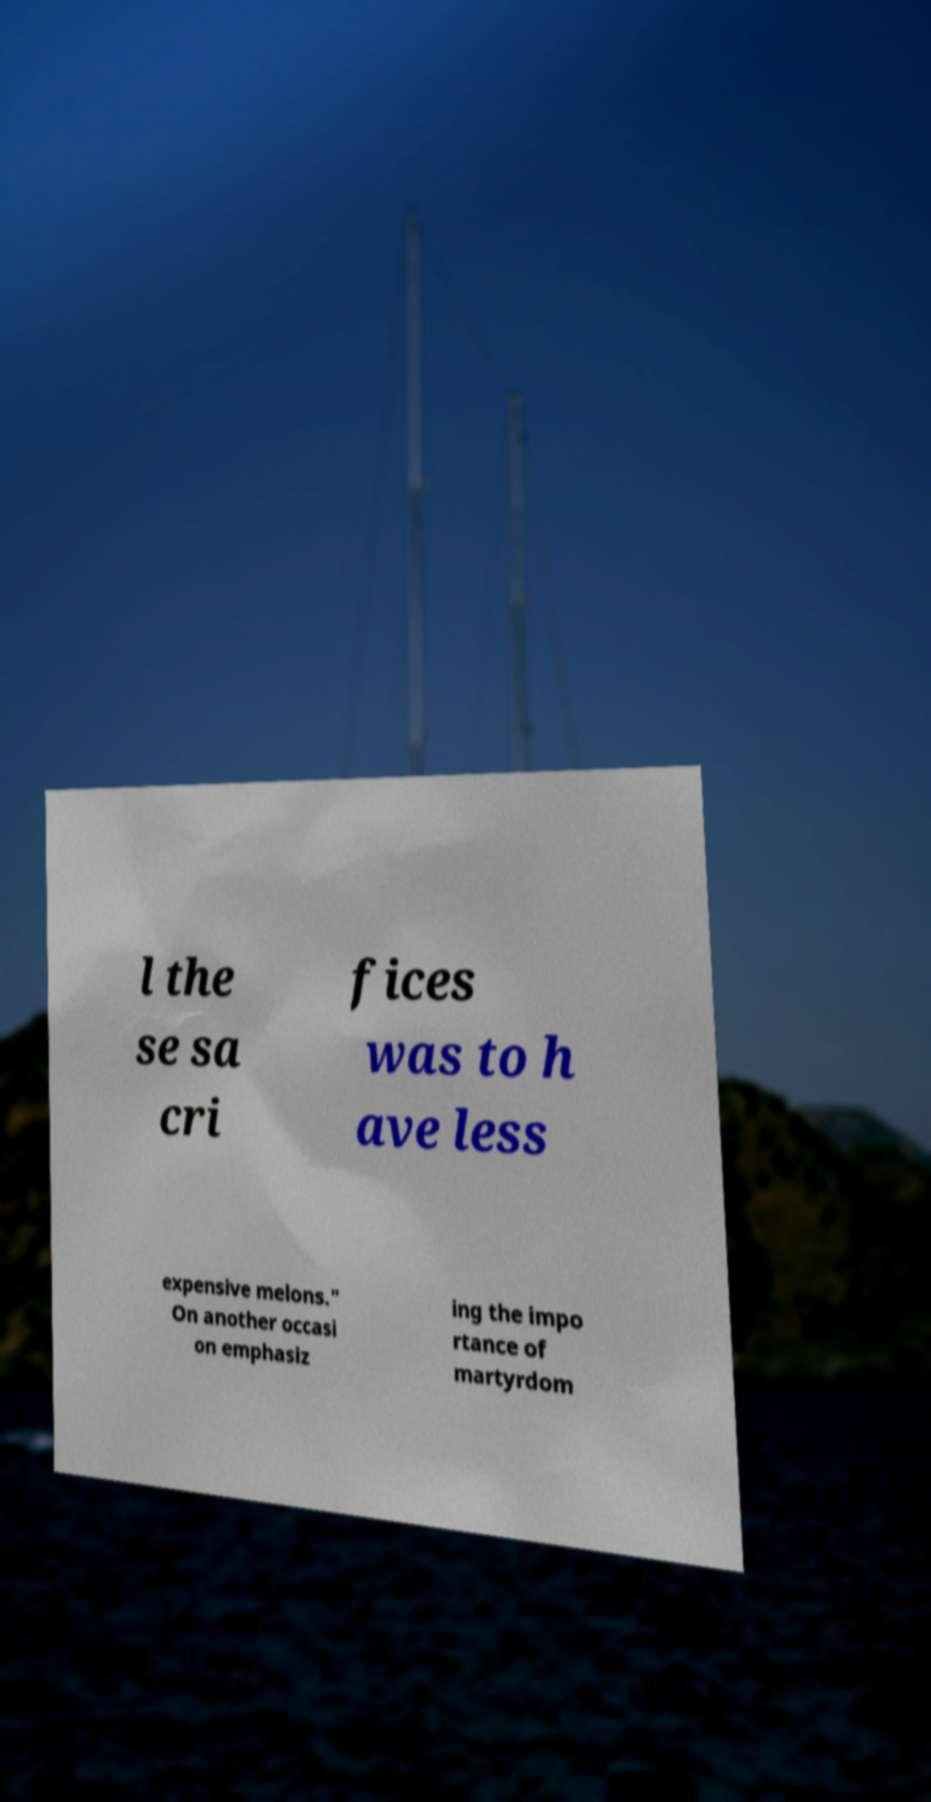Could you assist in decoding the text presented in this image and type it out clearly? l the se sa cri fices was to h ave less expensive melons." On another occasi on emphasiz ing the impo rtance of martyrdom 